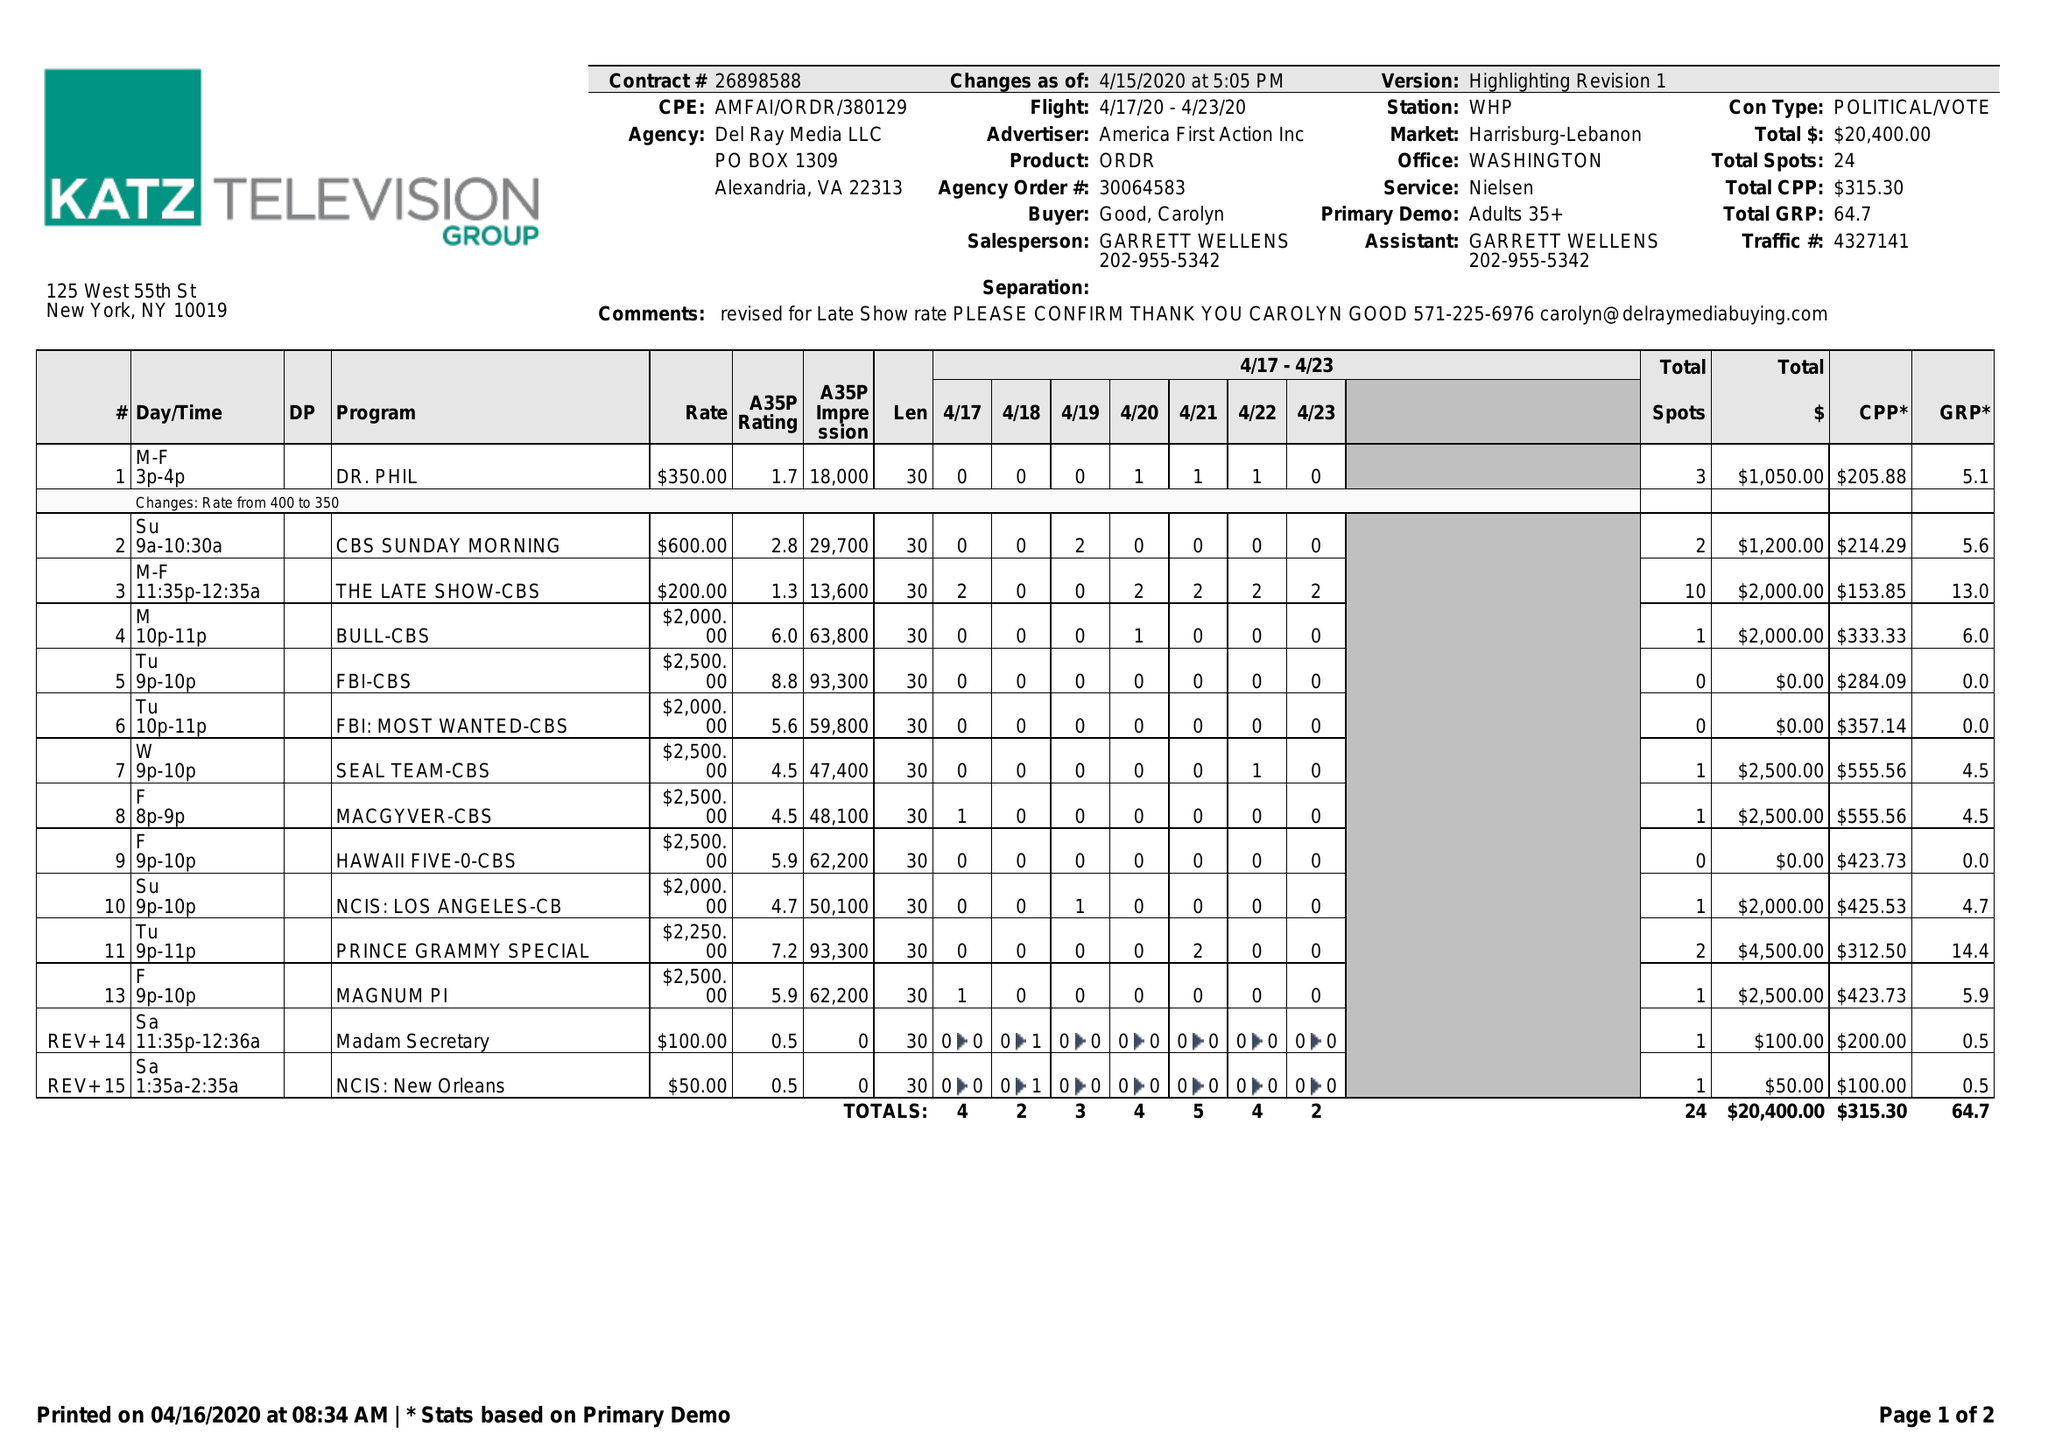What is the value for the flight_to?
Answer the question using a single word or phrase. 04/23/20 